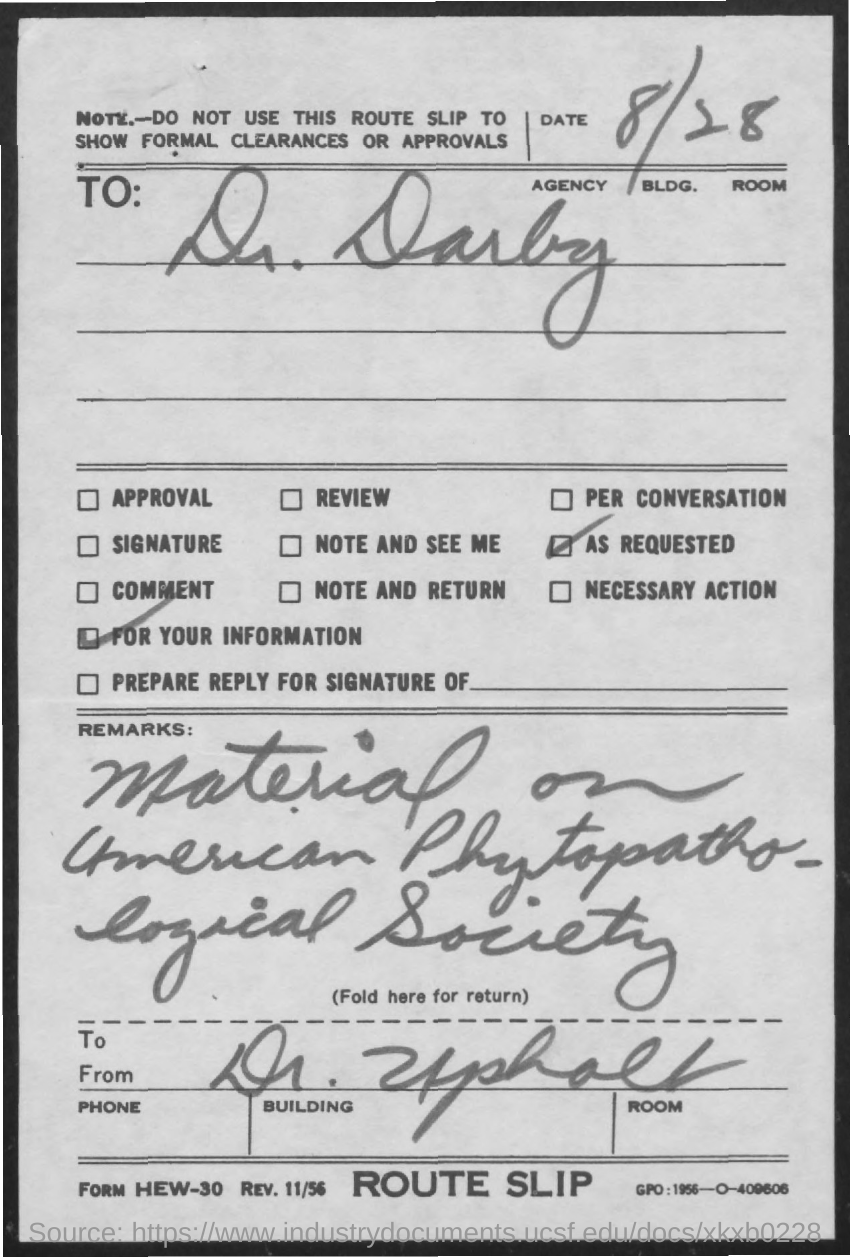Outline some significant characteristics in this image. The date mentioned on the route slip is August 28th. 